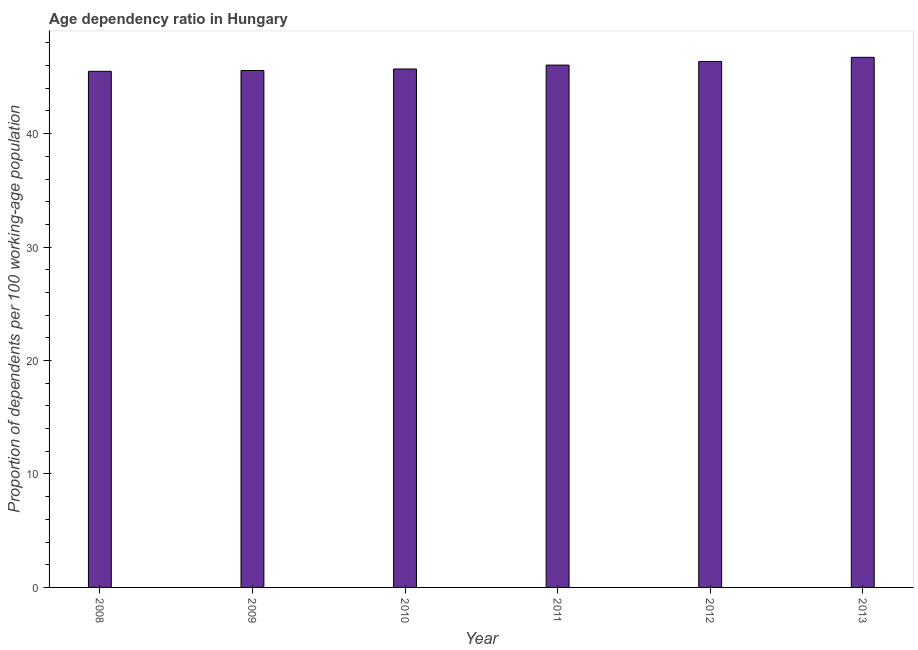Does the graph contain any zero values?
Provide a short and direct response. No. What is the title of the graph?
Make the answer very short. Age dependency ratio in Hungary. What is the label or title of the Y-axis?
Your answer should be compact. Proportion of dependents per 100 working-age population. What is the age dependency ratio in 2013?
Keep it short and to the point. 46.73. Across all years, what is the maximum age dependency ratio?
Offer a terse response. 46.73. Across all years, what is the minimum age dependency ratio?
Keep it short and to the point. 45.49. In which year was the age dependency ratio minimum?
Offer a very short reply. 2008. What is the sum of the age dependency ratio?
Keep it short and to the point. 275.89. What is the difference between the age dependency ratio in 2008 and 2010?
Give a very brief answer. -0.2. What is the average age dependency ratio per year?
Offer a terse response. 45.98. What is the median age dependency ratio?
Make the answer very short. 45.87. What is the ratio of the age dependency ratio in 2008 to that in 2009?
Offer a terse response. 1. Is the difference between the age dependency ratio in 2009 and 2013 greater than the difference between any two years?
Ensure brevity in your answer.  No. What is the difference between the highest and the second highest age dependency ratio?
Give a very brief answer. 0.37. Is the sum of the age dependency ratio in 2012 and 2013 greater than the maximum age dependency ratio across all years?
Offer a terse response. Yes. What is the difference between the highest and the lowest age dependency ratio?
Your response must be concise. 1.23. In how many years, is the age dependency ratio greater than the average age dependency ratio taken over all years?
Give a very brief answer. 3. How many bars are there?
Keep it short and to the point. 6. What is the difference between two consecutive major ticks on the Y-axis?
Make the answer very short. 10. Are the values on the major ticks of Y-axis written in scientific E-notation?
Ensure brevity in your answer.  No. What is the Proportion of dependents per 100 working-age population of 2008?
Keep it short and to the point. 45.49. What is the Proportion of dependents per 100 working-age population in 2009?
Ensure brevity in your answer.  45.57. What is the Proportion of dependents per 100 working-age population in 2010?
Provide a succinct answer. 45.7. What is the Proportion of dependents per 100 working-age population of 2011?
Offer a terse response. 46.04. What is the Proportion of dependents per 100 working-age population of 2012?
Ensure brevity in your answer.  46.36. What is the Proportion of dependents per 100 working-age population of 2013?
Offer a very short reply. 46.73. What is the difference between the Proportion of dependents per 100 working-age population in 2008 and 2009?
Make the answer very short. -0.07. What is the difference between the Proportion of dependents per 100 working-age population in 2008 and 2010?
Keep it short and to the point. -0.21. What is the difference between the Proportion of dependents per 100 working-age population in 2008 and 2011?
Give a very brief answer. -0.55. What is the difference between the Proportion of dependents per 100 working-age population in 2008 and 2012?
Offer a terse response. -0.87. What is the difference between the Proportion of dependents per 100 working-age population in 2008 and 2013?
Keep it short and to the point. -1.23. What is the difference between the Proportion of dependents per 100 working-age population in 2009 and 2010?
Make the answer very short. -0.13. What is the difference between the Proportion of dependents per 100 working-age population in 2009 and 2011?
Offer a very short reply. -0.48. What is the difference between the Proportion of dependents per 100 working-age population in 2009 and 2012?
Make the answer very short. -0.79. What is the difference between the Proportion of dependents per 100 working-age population in 2009 and 2013?
Your response must be concise. -1.16. What is the difference between the Proportion of dependents per 100 working-age population in 2010 and 2011?
Your response must be concise. -0.34. What is the difference between the Proportion of dependents per 100 working-age population in 2010 and 2012?
Your answer should be compact. -0.66. What is the difference between the Proportion of dependents per 100 working-age population in 2010 and 2013?
Give a very brief answer. -1.03. What is the difference between the Proportion of dependents per 100 working-age population in 2011 and 2012?
Your answer should be very brief. -0.32. What is the difference between the Proportion of dependents per 100 working-age population in 2011 and 2013?
Provide a short and direct response. -0.68. What is the difference between the Proportion of dependents per 100 working-age population in 2012 and 2013?
Provide a short and direct response. -0.37. What is the ratio of the Proportion of dependents per 100 working-age population in 2008 to that in 2010?
Offer a terse response. 1. What is the ratio of the Proportion of dependents per 100 working-age population in 2008 to that in 2013?
Your response must be concise. 0.97. What is the ratio of the Proportion of dependents per 100 working-age population in 2009 to that in 2013?
Provide a succinct answer. 0.97. What is the ratio of the Proportion of dependents per 100 working-age population in 2010 to that in 2011?
Offer a terse response. 0.99. What is the ratio of the Proportion of dependents per 100 working-age population in 2010 to that in 2012?
Provide a short and direct response. 0.99. What is the ratio of the Proportion of dependents per 100 working-age population in 2010 to that in 2013?
Your answer should be very brief. 0.98. What is the ratio of the Proportion of dependents per 100 working-age population in 2011 to that in 2013?
Ensure brevity in your answer.  0.98. 